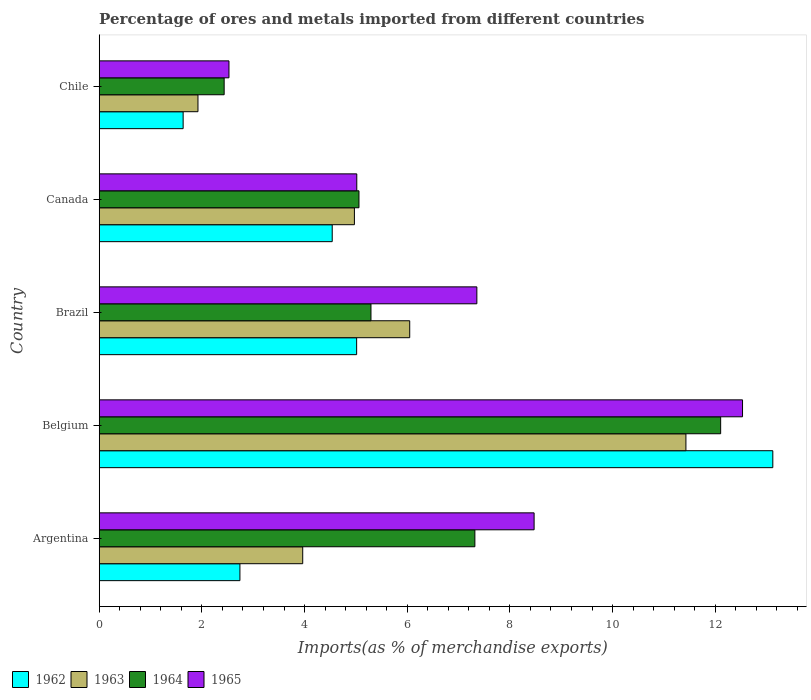How many different coloured bars are there?
Provide a short and direct response. 4. How many groups of bars are there?
Give a very brief answer. 5. Are the number of bars per tick equal to the number of legend labels?
Ensure brevity in your answer.  Yes. In how many cases, is the number of bars for a given country not equal to the number of legend labels?
Provide a succinct answer. 0. What is the percentage of imports to different countries in 1962 in Canada?
Keep it short and to the point. 4.54. Across all countries, what is the maximum percentage of imports to different countries in 1963?
Keep it short and to the point. 11.43. Across all countries, what is the minimum percentage of imports to different countries in 1963?
Ensure brevity in your answer.  1.92. What is the total percentage of imports to different countries in 1965 in the graph?
Provide a short and direct response. 35.91. What is the difference between the percentage of imports to different countries in 1964 in Brazil and that in Canada?
Make the answer very short. 0.23. What is the difference between the percentage of imports to different countries in 1964 in Argentina and the percentage of imports to different countries in 1963 in Canada?
Provide a short and direct response. 2.35. What is the average percentage of imports to different countries in 1964 per country?
Provide a succinct answer. 6.44. What is the difference between the percentage of imports to different countries in 1965 and percentage of imports to different countries in 1964 in Chile?
Your answer should be compact. 0.09. In how many countries, is the percentage of imports to different countries in 1964 greater than 9.2 %?
Offer a terse response. 1. What is the ratio of the percentage of imports to different countries in 1963 in Brazil to that in Chile?
Your response must be concise. 3.14. Is the percentage of imports to different countries in 1963 in Argentina less than that in Canada?
Keep it short and to the point. Yes. Is the difference between the percentage of imports to different countries in 1965 in Belgium and Brazil greater than the difference between the percentage of imports to different countries in 1964 in Belgium and Brazil?
Give a very brief answer. No. What is the difference between the highest and the second highest percentage of imports to different countries in 1962?
Offer a terse response. 8.11. What is the difference between the highest and the lowest percentage of imports to different countries in 1964?
Your answer should be very brief. 9.67. What does the 1st bar from the bottom in Belgium represents?
Your answer should be very brief. 1962. How many bars are there?
Offer a very short reply. 20. Are all the bars in the graph horizontal?
Provide a short and direct response. Yes. Does the graph contain any zero values?
Give a very brief answer. No. How are the legend labels stacked?
Make the answer very short. Horizontal. What is the title of the graph?
Offer a terse response. Percentage of ores and metals imported from different countries. What is the label or title of the X-axis?
Your response must be concise. Imports(as % of merchandise exports). What is the Imports(as % of merchandise exports) in 1962 in Argentina?
Make the answer very short. 2.74. What is the Imports(as % of merchandise exports) of 1963 in Argentina?
Give a very brief answer. 3.96. What is the Imports(as % of merchandise exports) in 1964 in Argentina?
Make the answer very short. 7.32. What is the Imports(as % of merchandise exports) of 1965 in Argentina?
Your answer should be very brief. 8.47. What is the Imports(as % of merchandise exports) of 1962 in Belgium?
Offer a very short reply. 13.12. What is the Imports(as % of merchandise exports) in 1963 in Belgium?
Your answer should be very brief. 11.43. What is the Imports(as % of merchandise exports) in 1964 in Belgium?
Your answer should be very brief. 12.11. What is the Imports(as % of merchandise exports) of 1965 in Belgium?
Your response must be concise. 12.53. What is the Imports(as % of merchandise exports) of 1962 in Brazil?
Give a very brief answer. 5.01. What is the Imports(as % of merchandise exports) in 1963 in Brazil?
Offer a terse response. 6.05. What is the Imports(as % of merchandise exports) of 1964 in Brazil?
Your response must be concise. 5.29. What is the Imports(as % of merchandise exports) of 1965 in Brazil?
Provide a succinct answer. 7.36. What is the Imports(as % of merchandise exports) of 1962 in Canada?
Provide a short and direct response. 4.54. What is the Imports(as % of merchandise exports) of 1963 in Canada?
Provide a succinct answer. 4.97. What is the Imports(as % of merchandise exports) of 1964 in Canada?
Offer a terse response. 5.06. What is the Imports(as % of merchandise exports) in 1965 in Canada?
Provide a succinct answer. 5.02. What is the Imports(as % of merchandise exports) of 1962 in Chile?
Ensure brevity in your answer.  1.63. What is the Imports(as % of merchandise exports) in 1963 in Chile?
Your response must be concise. 1.92. What is the Imports(as % of merchandise exports) in 1964 in Chile?
Offer a very short reply. 2.43. What is the Imports(as % of merchandise exports) in 1965 in Chile?
Keep it short and to the point. 2.53. Across all countries, what is the maximum Imports(as % of merchandise exports) in 1962?
Make the answer very short. 13.12. Across all countries, what is the maximum Imports(as % of merchandise exports) in 1963?
Give a very brief answer. 11.43. Across all countries, what is the maximum Imports(as % of merchandise exports) in 1964?
Provide a succinct answer. 12.11. Across all countries, what is the maximum Imports(as % of merchandise exports) in 1965?
Give a very brief answer. 12.53. Across all countries, what is the minimum Imports(as % of merchandise exports) of 1962?
Ensure brevity in your answer.  1.63. Across all countries, what is the minimum Imports(as % of merchandise exports) of 1963?
Your answer should be compact. 1.92. Across all countries, what is the minimum Imports(as % of merchandise exports) of 1964?
Provide a short and direct response. 2.43. Across all countries, what is the minimum Imports(as % of merchandise exports) in 1965?
Make the answer very short. 2.53. What is the total Imports(as % of merchandise exports) in 1962 in the graph?
Provide a short and direct response. 27.05. What is the total Imports(as % of merchandise exports) of 1963 in the graph?
Provide a short and direct response. 28.34. What is the total Imports(as % of merchandise exports) of 1964 in the graph?
Make the answer very short. 32.21. What is the total Imports(as % of merchandise exports) of 1965 in the graph?
Your response must be concise. 35.91. What is the difference between the Imports(as % of merchandise exports) of 1962 in Argentina and that in Belgium?
Your response must be concise. -10.38. What is the difference between the Imports(as % of merchandise exports) in 1963 in Argentina and that in Belgium?
Offer a terse response. -7.46. What is the difference between the Imports(as % of merchandise exports) in 1964 in Argentina and that in Belgium?
Provide a short and direct response. -4.79. What is the difference between the Imports(as % of merchandise exports) in 1965 in Argentina and that in Belgium?
Your response must be concise. -4.06. What is the difference between the Imports(as % of merchandise exports) of 1962 in Argentina and that in Brazil?
Provide a short and direct response. -2.27. What is the difference between the Imports(as % of merchandise exports) of 1963 in Argentina and that in Brazil?
Offer a very short reply. -2.08. What is the difference between the Imports(as % of merchandise exports) of 1964 in Argentina and that in Brazil?
Your response must be concise. 2.02. What is the difference between the Imports(as % of merchandise exports) of 1965 in Argentina and that in Brazil?
Your response must be concise. 1.12. What is the difference between the Imports(as % of merchandise exports) of 1962 in Argentina and that in Canada?
Offer a terse response. -1.8. What is the difference between the Imports(as % of merchandise exports) in 1963 in Argentina and that in Canada?
Provide a succinct answer. -1.01. What is the difference between the Imports(as % of merchandise exports) in 1964 in Argentina and that in Canada?
Make the answer very short. 2.26. What is the difference between the Imports(as % of merchandise exports) in 1965 in Argentina and that in Canada?
Provide a short and direct response. 3.45. What is the difference between the Imports(as % of merchandise exports) of 1962 in Argentina and that in Chile?
Your answer should be compact. 1.11. What is the difference between the Imports(as % of merchandise exports) in 1963 in Argentina and that in Chile?
Offer a very short reply. 2.04. What is the difference between the Imports(as % of merchandise exports) of 1964 in Argentina and that in Chile?
Offer a terse response. 4.88. What is the difference between the Imports(as % of merchandise exports) in 1965 in Argentina and that in Chile?
Keep it short and to the point. 5.94. What is the difference between the Imports(as % of merchandise exports) in 1962 in Belgium and that in Brazil?
Your answer should be very brief. 8.11. What is the difference between the Imports(as % of merchandise exports) in 1963 in Belgium and that in Brazil?
Give a very brief answer. 5.38. What is the difference between the Imports(as % of merchandise exports) of 1964 in Belgium and that in Brazil?
Provide a succinct answer. 6.81. What is the difference between the Imports(as % of merchandise exports) in 1965 in Belgium and that in Brazil?
Make the answer very short. 5.18. What is the difference between the Imports(as % of merchandise exports) in 1962 in Belgium and that in Canada?
Provide a short and direct response. 8.58. What is the difference between the Imports(as % of merchandise exports) of 1963 in Belgium and that in Canada?
Your response must be concise. 6.46. What is the difference between the Imports(as % of merchandise exports) in 1964 in Belgium and that in Canada?
Make the answer very short. 7.05. What is the difference between the Imports(as % of merchandise exports) of 1965 in Belgium and that in Canada?
Provide a succinct answer. 7.51. What is the difference between the Imports(as % of merchandise exports) of 1962 in Belgium and that in Chile?
Offer a very short reply. 11.49. What is the difference between the Imports(as % of merchandise exports) of 1963 in Belgium and that in Chile?
Offer a very short reply. 9.51. What is the difference between the Imports(as % of merchandise exports) in 1964 in Belgium and that in Chile?
Offer a very short reply. 9.67. What is the difference between the Imports(as % of merchandise exports) of 1965 in Belgium and that in Chile?
Your answer should be very brief. 10. What is the difference between the Imports(as % of merchandise exports) in 1962 in Brazil and that in Canada?
Keep it short and to the point. 0.48. What is the difference between the Imports(as % of merchandise exports) in 1963 in Brazil and that in Canada?
Provide a short and direct response. 1.08. What is the difference between the Imports(as % of merchandise exports) of 1964 in Brazil and that in Canada?
Your answer should be compact. 0.23. What is the difference between the Imports(as % of merchandise exports) in 1965 in Brazil and that in Canada?
Your response must be concise. 2.34. What is the difference between the Imports(as % of merchandise exports) in 1962 in Brazil and that in Chile?
Offer a terse response. 3.38. What is the difference between the Imports(as % of merchandise exports) of 1963 in Brazil and that in Chile?
Your answer should be compact. 4.12. What is the difference between the Imports(as % of merchandise exports) of 1964 in Brazil and that in Chile?
Give a very brief answer. 2.86. What is the difference between the Imports(as % of merchandise exports) in 1965 in Brazil and that in Chile?
Make the answer very short. 4.83. What is the difference between the Imports(as % of merchandise exports) of 1962 in Canada and that in Chile?
Ensure brevity in your answer.  2.9. What is the difference between the Imports(as % of merchandise exports) of 1963 in Canada and that in Chile?
Make the answer very short. 3.05. What is the difference between the Imports(as % of merchandise exports) of 1964 in Canada and that in Chile?
Offer a terse response. 2.63. What is the difference between the Imports(as % of merchandise exports) of 1965 in Canada and that in Chile?
Make the answer very short. 2.49. What is the difference between the Imports(as % of merchandise exports) of 1962 in Argentina and the Imports(as % of merchandise exports) of 1963 in Belgium?
Your response must be concise. -8.69. What is the difference between the Imports(as % of merchandise exports) of 1962 in Argentina and the Imports(as % of merchandise exports) of 1964 in Belgium?
Give a very brief answer. -9.37. What is the difference between the Imports(as % of merchandise exports) in 1962 in Argentina and the Imports(as % of merchandise exports) in 1965 in Belgium?
Your answer should be very brief. -9.79. What is the difference between the Imports(as % of merchandise exports) of 1963 in Argentina and the Imports(as % of merchandise exports) of 1964 in Belgium?
Keep it short and to the point. -8.14. What is the difference between the Imports(as % of merchandise exports) in 1963 in Argentina and the Imports(as % of merchandise exports) in 1965 in Belgium?
Your answer should be very brief. -8.57. What is the difference between the Imports(as % of merchandise exports) of 1964 in Argentina and the Imports(as % of merchandise exports) of 1965 in Belgium?
Your answer should be compact. -5.21. What is the difference between the Imports(as % of merchandise exports) of 1962 in Argentina and the Imports(as % of merchandise exports) of 1963 in Brazil?
Offer a terse response. -3.31. What is the difference between the Imports(as % of merchandise exports) in 1962 in Argentina and the Imports(as % of merchandise exports) in 1964 in Brazil?
Your answer should be compact. -2.55. What is the difference between the Imports(as % of merchandise exports) in 1962 in Argentina and the Imports(as % of merchandise exports) in 1965 in Brazil?
Ensure brevity in your answer.  -4.62. What is the difference between the Imports(as % of merchandise exports) in 1963 in Argentina and the Imports(as % of merchandise exports) in 1964 in Brazil?
Offer a very short reply. -1.33. What is the difference between the Imports(as % of merchandise exports) of 1963 in Argentina and the Imports(as % of merchandise exports) of 1965 in Brazil?
Offer a terse response. -3.39. What is the difference between the Imports(as % of merchandise exports) in 1964 in Argentina and the Imports(as % of merchandise exports) in 1965 in Brazil?
Give a very brief answer. -0.04. What is the difference between the Imports(as % of merchandise exports) of 1962 in Argentina and the Imports(as % of merchandise exports) of 1963 in Canada?
Offer a very short reply. -2.23. What is the difference between the Imports(as % of merchandise exports) in 1962 in Argentina and the Imports(as % of merchandise exports) in 1964 in Canada?
Give a very brief answer. -2.32. What is the difference between the Imports(as % of merchandise exports) of 1962 in Argentina and the Imports(as % of merchandise exports) of 1965 in Canada?
Make the answer very short. -2.28. What is the difference between the Imports(as % of merchandise exports) of 1963 in Argentina and the Imports(as % of merchandise exports) of 1964 in Canada?
Ensure brevity in your answer.  -1.1. What is the difference between the Imports(as % of merchandise exports) of 1963 in Argentina and the Imports(as % of merchandise exports) of 1965 in Canada?
Your answer should be very brief. -1.05. What is the difference between the Imports(as % of merchandise exports) in 1964 in Argentina and the Imports(as % of merchandise exports) in 1965 in Canada?
Offer a very short reply. 2.3. What is the difference between the Imports(as % of merchandise exports) in 1962 in Argentina and the Imports(as % of merchandise exports) in 1963 in Chile?
Your response must be concise. 0.82. What is the difference between the Imports(as % of merchandise exports) in 1962 in Argentina and the Imports(as % of merchandise exports) in 1964 in Chile?
Give a very brief answer. 0.31. What is the difference between the Imports(as % of merchandise exports) in 1962 in Argentina and the Imports(as % of merchandise exports) in 1965 in Chile?
Ensure brevity in your answer.  0.21. What is the difference between the Imports(as % of merchandise exports) of 1963 in Argentina and the Imports(as % of merchandise exports) of 1964 in Chile?
Offer a terse response. 1.53. What is the difference between the Imports(as % of merchandise exports) in 1963 in Argentina and the Imports(as % of merchandise exports) in 1965 in Chile?
Keep it short and to the point. 1.44. What is the difference between the Imports(as % of merchandise exports) of 1964 in Argentina and the Imports(as % of merchandise exports) of 1965 in Chile?
Ensure brevity in your answer.  4.79. What is the difference between the Imports(as % of merchandise exports) in 1962 in Belgium and the Imports(as % of merchandise exports) in 1963 in Brazil?
Give a very brief answer. 7.07. What is the difference between the Imports(as % of merchandise exports) of 1962 in Belgium and the Imports(as % of merchandise exports) of 1964 in Brazil?
Offer a terse response. 7.83. What is the difference between the Imports(as % of merchandise exports) of 1962 in Belgium and the Imports(as % of merchandise exports) of 1965 in Brazil?
Your answer should be very brief. 5.77. What is the difference between the Imports(as % of merchandise exports) of 1963 in Belgium and the Imports(as % of merchandise exports) of 1964 in Brazil?
Make the answer very short. 6.14. What is the difference between the Imports(as % of merchandise exports) in 1963 in Belgium and the Imports(as % of merchandise exports) in 1965 in Brazil?
Provide a short and direct response. 4.07. What is the difference between the Imports(as % of merchandise exports) in 1964 in Belgium and the Imports(as % of merchandise exports) in 1965 in Brazil?
Make the answer very short. 4.75. What is the difference between the Imports(as % of merchandise exports) of 1962 in Belgium and the Imports(as % of merchandise exports) of 1963 in Canada?
Your answer should be compact. 8.15. What is the difference between the Imports(as % of merchandise exports) in 1962 in Belgium and the Imports(as % of merchandise exports) in 1964 in Canada?
Your response must be concise. 8.06. What is the difference between the Imports(as % of merchandise exports) of 1962 in Belgium and the Imports(as % of merchandise exports) of 1965 in Canada?
Provide a succinct answer. 8.1. What is the difference between the Imports(as % of merchandise exports) in 1963 in Belgium and the Imports(as % of merchandise exports) in 1964 in Canada?
Offer a terse response. 6.37. What is the difference between the Imports(as % of merchandise exports) of 1963 in Belgium and the Imports(as % of merchandise exports) of 1965 in Canada?
Provide a short and direct response. 6.41. What is the difference between the Imports(as % of merchandise exports) of 1964 in Belgium and the Imports(as % of merchandise exports) of 1965 in Canada?
Give a very brief answer. 7.09. What is the difference between the Imports(as % of merchandise exports) in 1962 in Belgium and the Imports(as % of merchandise exports) in 1963 in Chile?
Provide a short and direct response. 11.2. What is the difference between the Imports(as % of merchandise exports) of 1962 in Belgium and the Imports(as % of merchandise exports) of 1964 in Chile?
Provide a short and direct response. 10.69. What is the difference between the Imports(as % of merchandise exports) of 1962 in Belgium and the Imports(as % of merchandise exports) of 1965 in Chile?
Your answer should be very brief. 10.59. What is the difference between the Imports(as % of merchandise exports) of 1963 in Belgium and the Imports(as % of merchandise exports) of 1964 in Chile?
Make the answer very short. 9. What is the difference between the Imports(as % of merchandise exports) of 1963 in Belgium and the Imports(as % of merchandise exports) of 1965 in Chile?
Offer a terse response. 8.9. What is the difference between the Imports(as % of merchandise exports) of 1964 in Belgium and the Imports(as % of merchandise exports) of 1965 in Chile?
Your answer should be compact. 9.58. What is the difference between the Imports(as % of merchandise exports) in 1962 in Brazil and the Imports(as % of merchandise exports) in 1963 in Canada?
Make the answer very short. 0.04. What is the difference between the Imports(as % of merchandise exports) in 1962 in Brazil and the Imports(as % of merchandise exports) in 1964 in Canada?
Your answer should be compact. -0.05. What is the difference between the Imports(as % of merchandise exports) in 1962 in Brazil and the Imports(as % of merchandise exports) in 1965 in Canada?
Your answer should be compact. -0. What is the difference between the Imports(as % of merchandise exports) of 1963 in Brazil and the Imports(as % of merchandise exports) of 1965 in Canada?
Make the answer very short. 1.03. What is the difference between the Imports(as % of merchandise exports) of 1964 in Brazil and the Imports(as % of merchandise exports) of 1965 in Canada?
Keep it short and to the point. 0.28. What is the difference between the Imports(as % of merchandise exports) of 1962 in Brazil and the Imports(as % of merchandise exports) of 1963 in Chile?
Provide a short and direct response. 3.09. What is the difference between the Imports(as % of merchandise exports) in 1962 in Brazil and the Imports(as % of merchandise exports) in 1964 in Chile?
Your response must be concise. 2.58. What is the difference between the Imports(as % of merchandise exports) in 1962 in Brazil and the Imports(as % of merchandise exports) in 1965 in Chile?
Provide a succinct answer. 2.49. What is the difference between the Imports(as % of merchandise exports) in 1963 in Brazil and the Imports(as % of merchandise exports) in 1964 in Chile?
Provide a short and direct response. 3.61. What is the difference between the Imports(as % of merchandise exports) of 1963 in Brazil and the Imports(as % of merchandise exports) of 1965 in Chile?
Offer a very short reply. 3.52. What is the difference between the Imports(as % of merchandise exports) in 1964 in Brazil and the Imports(as % of merchandise exports) in 1965 in Chile?
Provide a succinct answer. 2.77. What is the difference between the Imports(as % of merchandise exports) of 1962 in Canada and the Imports(as % of merchandise exports) of 1963 in Chile?
Make the answer very short. 2.62. What is the difference between the Imports(as % of merchandise exports) of 1962 in Canada and the Imports(as % of merchandise exports) of 1964 in Chile?
Keep it short and to the point. 2.11. What is the difference between the Imports(as % of merchandise exports) of 1962 in Canada and the Imports(as % of merchandise exports) of 1965 in Chile?
Offer a terse response. 2.01. What is the difference between the Imports(as % of merchandise exports) in 1963 in Canada and the Imports(as % of merchandise exports) in 1964 in Chile?
Keep it short and to the point. 2.54. What is the difference between the Imports(as % of merchandise exports) in 1963 in Canada and the Imports(as % of merchandise exports) in 1965 in Chile?
Offer a terse response. 2.44. What is the difference between the Imports(as % of merchandise exports) in 1964 in Canada and the Imports(as % of merchandise exports) in 1965 in Chile?
Your answer should be compact. 2.53. What is the average Imports(as % of merchandise exports) in 1962 per country?
Ensure brevity in your answer.  5.41. What is the average Imports(as % of merchandise exports) in 1963 per country?
Keep it short and to the point. 5.67. What is the average Imports(as % of merchandise exports) of 1964 per country?
Ensure brevity in your answer.  6.44. What is the average Imports(as % of merchandise exports) of 1965 per country?
Offer a very short reply. 7.18. What is the difference between the Imports(as % of merchandise exports) in 1962 and Imports(as % of merchandise exports) in 1963 in Argentina?
Give a very brief answer. -1.22. What is the difference between the Imports(as % of merchandise exports) of 1962 and Imports(as % of merchandise exports) of 1964 in Argentina?
Ensure brevity in your answer.  -4.58. What is the difference between the Imports(as % of merchandise exports) of 1962 and Imports(as % of merchandise exports) of 1965 in Argentina?
Give a very brief answer. -5.73. What is the difference between the Imports(as % of merchandise exports) in 1963 and Imports(as % of merchandise exports) in 1964 in Argentina?
Make the answer very short. -3.35. What is the difference between the Imports(as % of merchandise exports) in 1963 and Imports(as % of merchandise exports) in 1965 in Argentina?
Your response must be concise. -4.51. What is the difference between the Imports(as % of merchandise exports) of 1964 and Imports(as % of merchandise exports) of 1965 in Argentina?
Make the answer very short. -1.15. What is the difference between the Imports(as % of merchandise exports) in 1962 and Imports(as % of merchandise exports) in 1963 in Belgium?
Provide a short and direct response. 1.69. What is the difference between the Imports(as % of merchandise exports) of 1962 and Imports(as % of merchandise exports) of 1964 in Belgium?
Offer a terse response. 1.02. What is the difference between the Imports(as % of merchandise exports) of 1962 and Imports(as % of merchandise exports) of 1965 in Belgium?
Your answer should be very brief. 0.59. What is the difference between the Imports(as % of merchandise exports) of 1963 and Imports(as % of merchandise exports) of 1964 in Belgium?
Your answer should be compact. -0.68. What is the difference between the Imports(as % of merchandise exports) of 1963 and Imports(as % of merchandise exports) of 1965 in Belgium?
Offer a very short reply. -1.1. What is the difference between the Imports(as % of merchandise exports) in 1964 and Imports(as % of merchandise exports) in 1965 in Belgium?
Give a very brief answer. -0.43. What is the difference between the Imports(as % of merchandise exports) of 1962 and Imports(as % of merchandise exports) of 1963 in Brazil?
Your response must be concise. -1.03. What is the difference between the Imports(as % of merchandise exports) in 1962 and Imports(as % of merchandise exports) in 1964 in Brazil?
Offer a very short reply. -0.28. What is the difference between the Imports(as % of merchandise exports) of 1962 and Imports(as % of merchandise exports) of 1965 in Brazil?
Give a very brief answer. -2.34. What is the difference between the Imports(as % of merchandise exports) in 1963 and Imports(as % of merchandise exports) in 1964 in Brazil?
Ensure brevity in your answer.  0.75. What is the difference between the Imports(as % of merchandise exports) of 1963 and Imports(as % of merchandise exports) of 1965 in Brazil?
Ensure brevity in your answer.  -1.31. What is the difference between the Imports(as % of merchandise exports) of 1964 and Imports(as % of merchandise exports) of 1965 in Brazil?
Keep it short and to the point. -2.06. What is the difference between the Imports(as % of merchandise exports) of 1962 and Imports(as % of merchandise exports) of 1963 in Canada?
Your answer should be very brief. -0.43. What is the difference between the Imports(as % of merchandise exports) in 1962 and Imports(as % of merchandise exports) in 1964 in Canada?
Give a very brief answer. -0.52. What is the difference between the Imports(as % of merchandise exports) in 1962 and Imports(as % of merchandise exports) in 1965 in Canada?
Give a very brief answer. -0.48. What is the difference between the Imports(as % of merchandise exports) of 1963 and Imports(as % of merchandise exports) of 1964 in Canada?
Keep it short and to the point. -0.09. What is the difference between the Imports(as % of merchandise exports) of 1963 and Imports(as % of merchandise exports) of 1965 in Canada?
Provide a succinct answer. -0.05. What is the difference between the Imports(as % of merchandise exports) in 1964 and Imports(as % of merchandise exports) in 1965 in Canada?
Offer a terse response. 0.04. What is the difference between the Imports(as % of merchandise exports) in 1962 and Imports(as % of merchandise exports) in 1963 in Chile?
Give a very brief answer. -0.29. What is the difference between the Imports(as % of merchandise exports) of 1962 and Imports(as % of merchandise exports) of 1964 in Chile?
Ensure brevity in your answer.  -0.8. What is the difference between the Imports(as % of merchandise exports) in 1962 and Imports(as % of merchandise exports) in 1965 in Chile?
Provide a short and direct response. -0.89. What is the difference between the Imports(as % of merchandise exports) of 1963 and Imports(as % of merchandise exports) of 1964 in Chile?
Offer a very short reply. -0.51. What is the difference between the Imports(as % of merchandise exports) in 1963 and Imports(as % of merchandise exports) in 1965 in Chile?
Offer a terse response. -0.6. What is the difference between the Imports(as % of merchandise exports) in 1964 and Imports(as % of merchandise exports) in 1965 in Chile?
Provide a short and direct response. -0.09. What is the ratio of the Imports(as % of merchandise exports) of 1962 in Argentina to that in Belgium?
Your response must be concise. 0.21. What is the ratio of the Imports(as % of merchandise exports) in 1963 in Argentina to that in Belgium?
Your response must be concise. 0.35. What is the ratio of the Imports(as % of merchandise exports) of 1964 in Argentina to that in Belgium?
Keep it short and to the point. 0.6. What is the ratio of the Imports(as % of merchandise exports) in 1965 in Argentina to that in Belgium?
Your answer should be compact. 0.68. What is the ratio of the Imports(as % of merchandise exports) in 1962 in Argentina to that in Brazil?
Ensure brevity in your answer.  0.55. What is the ratio of the Imports(as % of merchandise exports) in 1963 in Argentina to that in Brazil?
Keep it short and to the point. 0.66. What is the ratio of the Imports(as % of merchandise exports) of 1964 in Argentina to that in Brazil?
Ensure brevity in your answer.  1.38. What is the ratio of the Imports(as % of merchandise exports) of 1965 in Argentina to that in Brazil?
Provide a short and direct response. 1.15. What is the ratio of the Imports(as % of merchandise exports) in 1962 in Argentina to that in Canada?
Provide a short and direct response. 0.6. What is the ratio of the Imports(as % of merchandise exports) of 1963 in Argentina to that in Canada?
Offer a terse response. 0.8. What is the ratio of the Imports(as % of merchandise exports) in 1964 in Argentina to that in Canada?
Give a very brief answer. 1.45. What is the ratio of the Imports(as % of merchandise exports) of 1965 in Argentina to that in Canada?
Ensure brevity in your answer.  1.69. What is the ratio of the Imports(as % of merchandise exports) in 1962 in Argentina to that in Chile?
Your response must be concise. 1.68. What is the ratio of the Imports(as % of merchandise exports) of 1963 in Argentina to that in Chile?
Provide a succinct answer. 2.06. What is the ratio of the Imports(as % of merchandise exports) in 1964 in Argentina to that in Chile?
Offer a very short reply. 3.01. What is the ratio of the Imports(as % of merchandise exports) of 1965 in Argentina to that in Chile?
Offer a very short reply. 3.35. What is the ratio of the Imports(as % of merchandise exports) of 1962 in Belgium to that in Brazil?
Offer a terse response. 2.62. What is the ratio of the Imports(as % of merchandise exports) of 1963 in Belgium to that in Brazil?
Your response must be concise. 1.89. What is the ratio of the Imports(as % of merchandise exports) in 1964 in Belgium to that in Brazil?
Your answer should be very brief. 2.29. What is the ratio of the Imports(as % of merchandise exports) of 1965 in Belgium to that in Brazil?
Your response must be concise. 1.7. What is the ratio of the Imports(as % of merchandise exports) of 1962 in Belgium to that in Canada?
Provide a succinct answer. 2.89. What is the ratio of the Imports(as % of merchandise exports) of 1963 in Belgium to that in Canada?
Keep it short and to the point. 2.3. What is the ratio of the Imports(as % of merchandise exports) of 1964 in Belgium to that in Canada?
Give a very brief answer. 2.39. What is the ratio of the Imports(as % of merchandise exports) in 1965 in Belgium to that in Canada?
Give a very brief answer. 2.5. What is the ratio of the Imports(as % of merchandise exports) in 1962 in Belgium to that in Chile?
Your answer should be very brief. 8.03. What is the ratio of the Imports(as % of merchandise exports) in 1963 in Belgium to that in Chile?
Give a very brief answer. 5.94. What is the ratio of the Imports(as % of merchandise exports) in 1964 in Belgium to that in Chile?
Ensure brevity in your answer.  4.97. What is the ratio of the Imports(as % of merchandise exports) of 1965 in Belgium to that in Chile?
Your response must be concise. 4.96. What is the ratio of the Imports(as % of merchandise exports) in 1962 in Brazil to that in Canada?
Keep it short and to the point. 1.1. What is the ratio of the Imports(as % of merchandise exports) in 1963 in Brazil to that in Canada?
Offer a very short reply. 1.22. What is the ratio of the Imports(as % of merchandise exports) of 1964 in Brazil to that in Canada?
Ensure brevity in your answer.  1.05. What is the ratio of the Imports(as % of merchandise exports) in 1965 in Brazil to that in Canada?
Keep it short and to the point. 1.47. What is the ratio of the Imports(as % of merchandise exports) in 1962 in Brazil to that in Chile?
Provide a short and direct response. 3.07. What is the ratio of the Imports(as % of merchandise exports) in 1963 in Brazil to that in Chile?
Provide a succinct answer. 3.14. What is the ratio of the Imports(as % of merchandise exports) in 1964 in Brazil to that in Chile?
Your answer should be compact. 2.18. What is the ratio of the Imports(as % of merchandise exports) in 1965 in Brazil to that in Chile?
Your answer should be compact. 2.91. What is the ratio of the Imports(as % of merchandise exports) of 1962 in Canada to that in Chile?
Provide a short and direct response. 2.78. What is the ratio of the Imports(as % of merchandise exports) in 1963 in Canada to that in Chile?
Provide a short and direct response. 2.58. What is the ratio of the Imports(as % of merchandise exports) of 1964 in Canada to that in Chile?
Ensure brevity in your answer.  2.08. What is the ratio of the Imports(as % of merchandise exports) of 1965 in Canada to that in Chile?
Offer a terse response. 1.99. What is the difference between the highest and the second highest Imports(as % of merchandise exports) of 1962?
Provide a short and direct response. 8.11. What is the difference between the highest and the second highest Imports(as % of merchandise exports) in 1963?
Your answer should be very brief. 5.38. What is the difference between the highest and the second highest Imports(as % of merchandise exports) of 1964?
Provide a short and direct response. 4.79. What is the difference between the highest and the second highest Imports(as % of merchandise exports) of 1965?
Offer a terse response. 4.06. What is the difference between the highest and the lowest Imports(as % of merchandise exports) in 1962?
Offer a very short reply. 11.49. What is the difference between the highest and the lowest Imports(as % of merchandise exports) of 1963?
Your answer should be very brief. 9.51. What is the difference between the highest and the lowest Imports(as % of merchandise exports) in 1964?
Your answer should be very brief. 9.67. What is the difference between the highest and the lowest Imports(as % of merchandise exports) of 1965?
Offer a terse response. 10. 